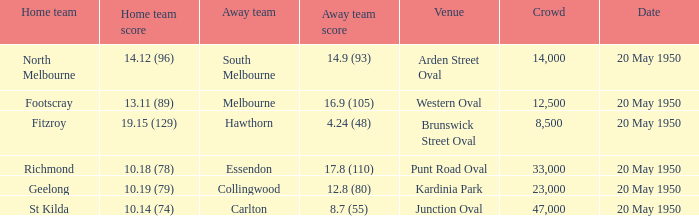In which place did the away team manage to score 14.9 (93)? Arden Street Oval. 